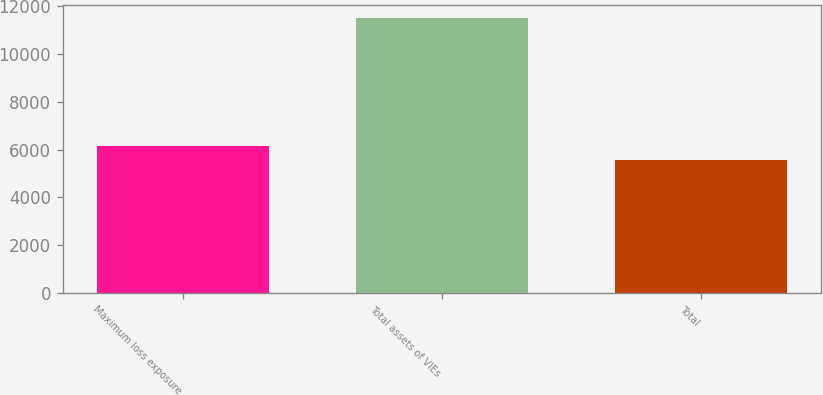<chart> <loc_0><loc_0><loc_500><loc_500><bar_chart><fcel>Maximum loss exposure<fcel>Total assets of VIEs<fcel>Total<nl><fcel>6158.3<fcel>11507<fcel>5564<nl></chart> 